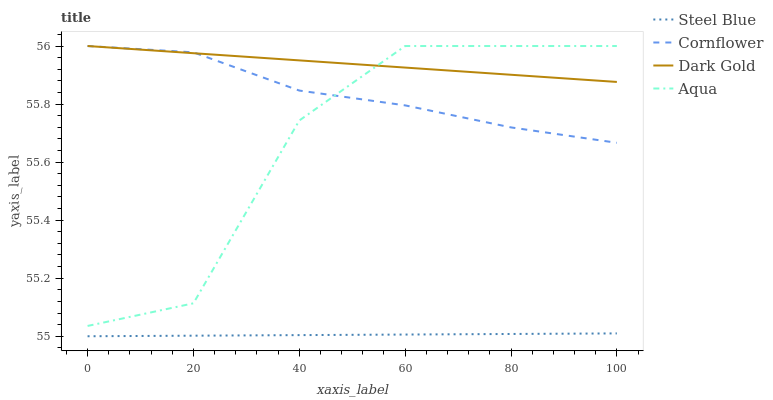Does Steel Blue have the minimum area under the curve?
Answer yes or no. Yes. Does Dark Gold have the maximum area under the curve?
Answer yes or no. Yes. Does Aqua have the minimum area under the curve?
Answer yes or no. No. Does Aqua have the maximum area under the curve?
Answer yes or no. No. Is Steel Blue the smoothest?
Answer yes or no. Yes. Is Aqua the roughest?
Answer yes or no. Yes. Is Aqua the smoothest?
Answer yes or no. No. Is Steel Blue the roughest?
Answer yes or no. No. Does Aqua have the lowest value?
Answer yes or no. No. Does Steel Blue have the highest value?
Answer yes or no. No. Is Steel Blue less than Cornflower?
Answer yes or no. Yes. Is Dark Gold greater than Steel Blue?
Answer yes or no. Yes. Does Steel Blue intersect Cornflower?
Answer yes or no. No. 